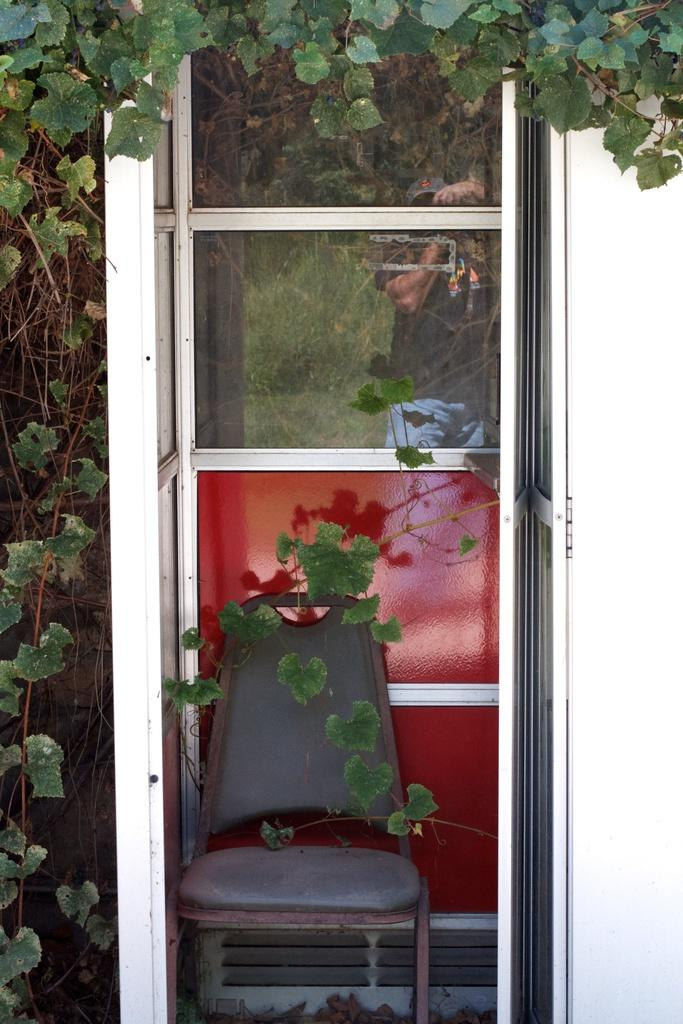What type of object can be seen in the image that allows entry or exit? There is a door in the image that allows entry or exit. What type of furniture is present in the image? There is a chair in the image. What type of living organisms can be seen in the image? There are plants in the image. What type of bone can be seen in the image? There is no bone present in the image. What type of knowledge is depicted in the image? There is no knowledge depicted in the image; it features a door, a chair, and plants. 